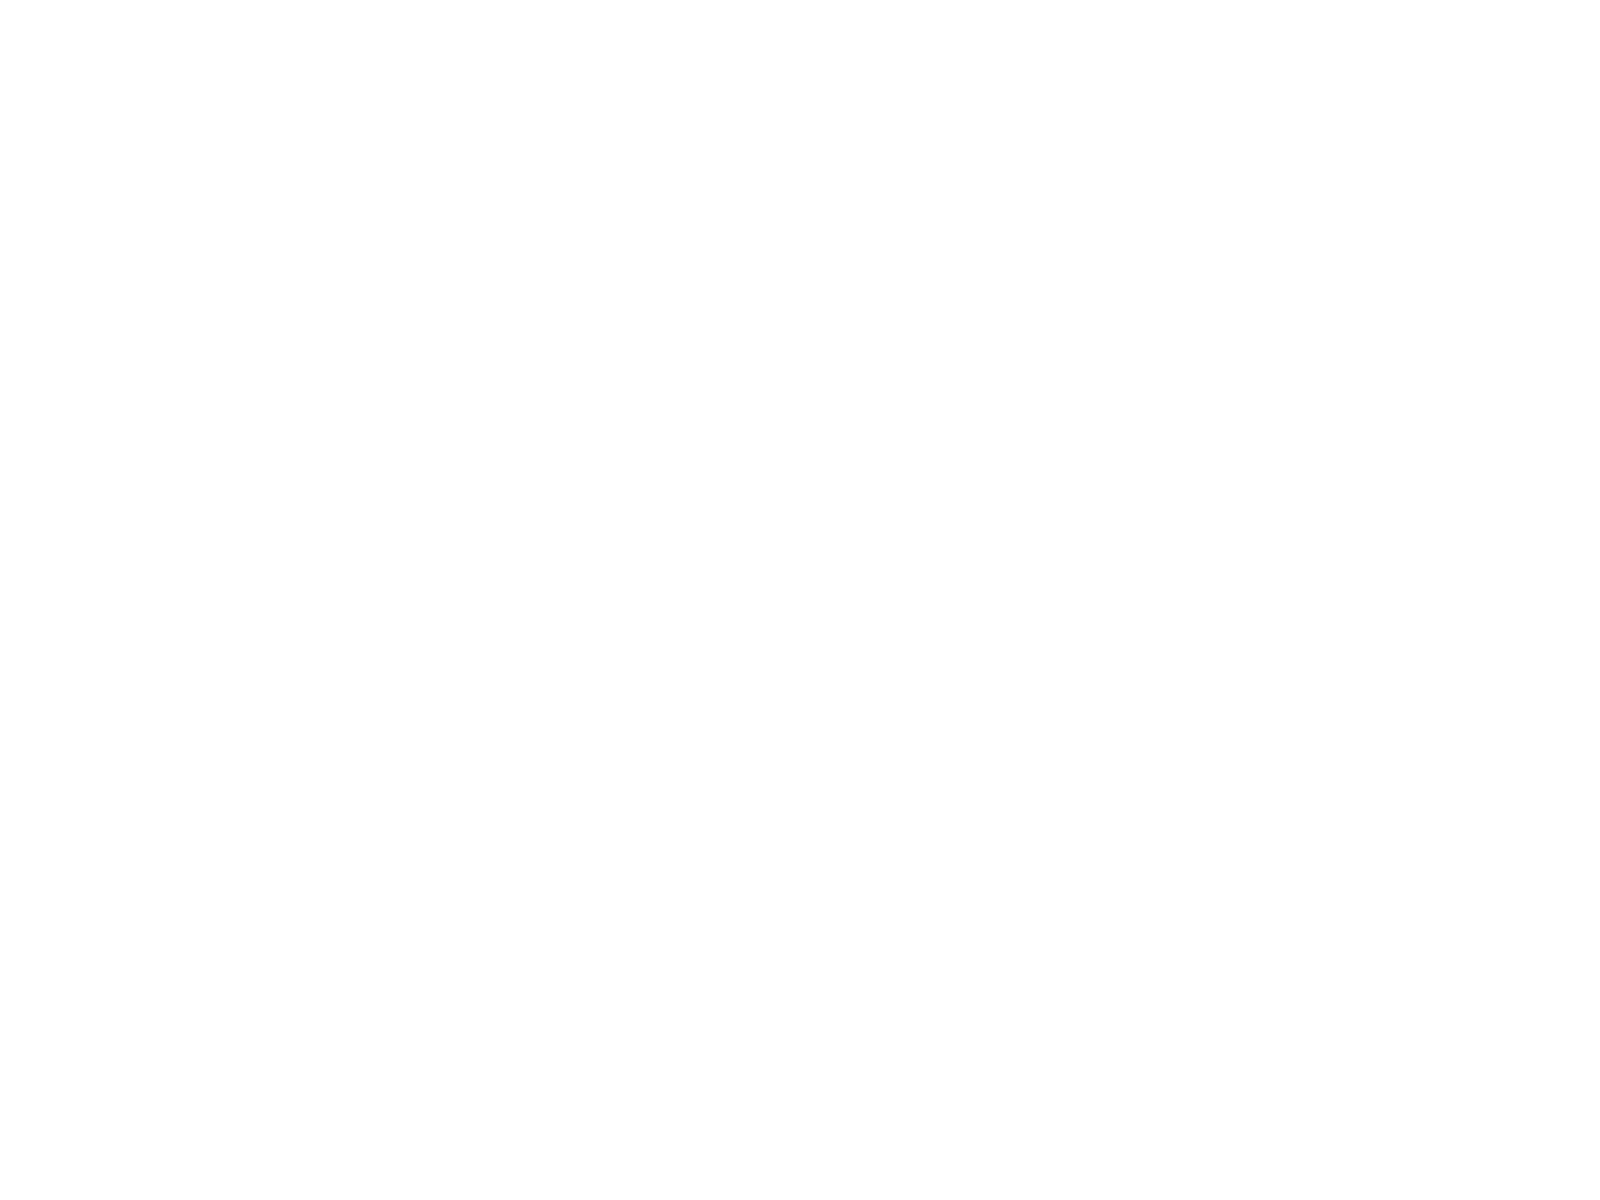<chart> <loc_0><loc_0><loc_500><loc_500><pie_chart><fcel>3340 - 8173<fcel>8174 - 10591<fcel>10592 - 11176<fcel>3340 - 11176<nl><fcel>18.1%<fcel>28.42%<fcel>30.22%<fcel>23.27%<nl></chart> 